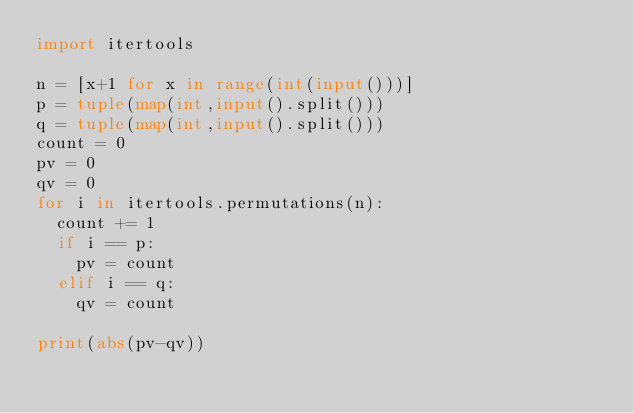<code> <loc_0><loc_0><loc_500><loc_500><_Python_>import itertools

n = [x+1 for x in range(int(input()))]
p = tuple(map(int,input().split()))
q = tuple(map(int,input().split()))
count = 0
pv = 0
qv = 0
for i in itertools.permutations(n):
  count += 1
  if i == p:
    pv = count
  elif i == q:
    qv = count

print(abs(pv-qv))</code> 